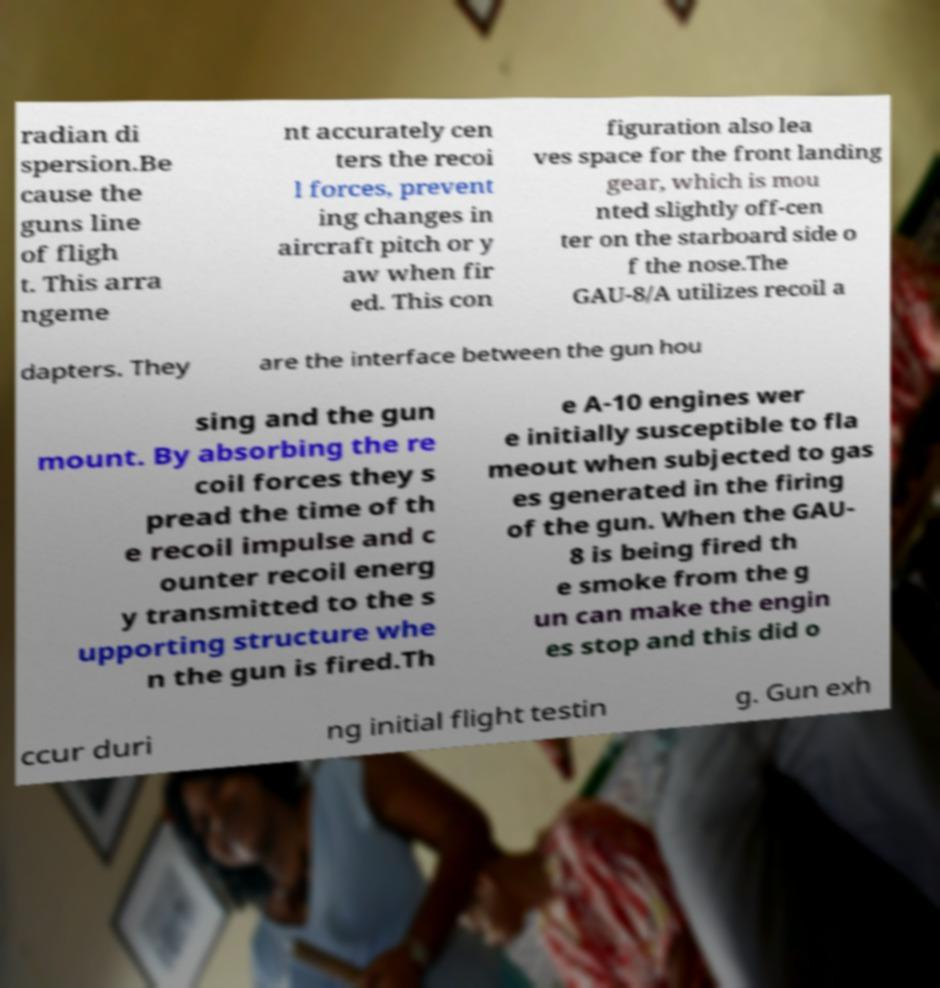Could you assist in decoding the text presented in this image and type it out clearly? radian di spersion.Be cause the guns line of fligh t. This arra ngeme nt accurately cen ters the recoi l forces, prevent ing changes in aircraft pitch or y aw when fir ed. This con figuration also lea ves space for the front landing gear, which is mou nted slightly off-cen ter on the starboard side o f the nose.The GAU-8/A utilizes recoil a dapters. They are the interface between the gun hou sing and the gun mount. By absorbing the re coil forces they s pread the time of th e recoil impulse and c ounter recoil energ y transmitted to the s upporting structure whe n the gun is fired.Th e A-10 engines wer e initially susceptible to fla meout when subjected to gas es generated in the firing of the gun. When the GAU- 8 is being fired th e smoke from the g un can make the engin es stop and this did o ccur duri ng initial flight testin g. Gun exh 